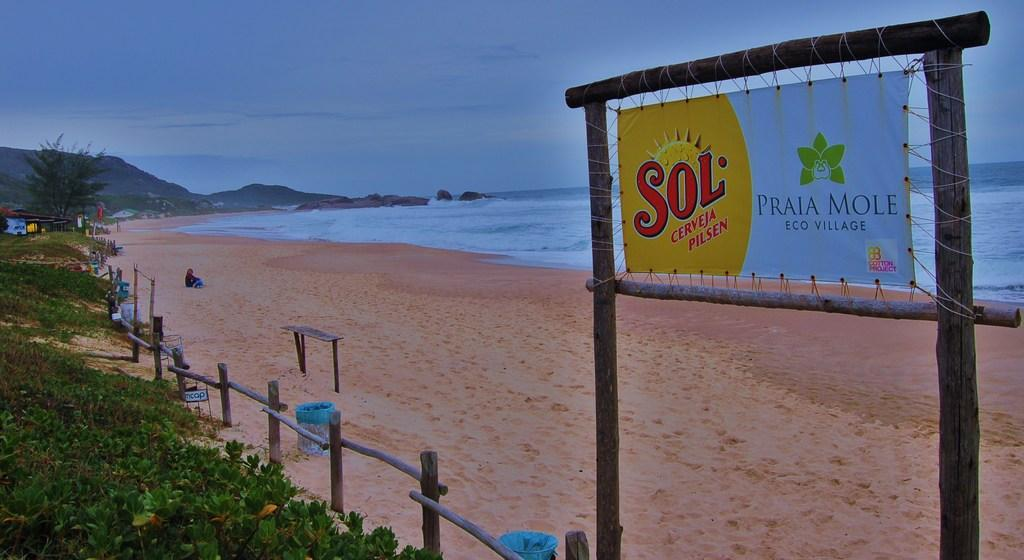What can be seen in the sky in the image? The sky with clouds is visible in the image. What type of natural vegetation is present in the image? There are trees and plants in the image. What type of structures can be seen in the image? There are sheds in the image. What type of terrain is visible in the image? Rocks are visible in the image. What large body of water is present in the image? The sea is in the image. What is the person in the image doing? There is a person sitting on the seashore. What type of barrier is present in the image? A fence is present in the image. What type of sign is visible in the image? A name board is in the image. What type of zinc is being used to help the sail in the image? There is no zinc or sail present in the image. How does the person in the image help the sail in the image? The person in the image is sitting on the seashore, and there is no sail present in the image for them to help. 